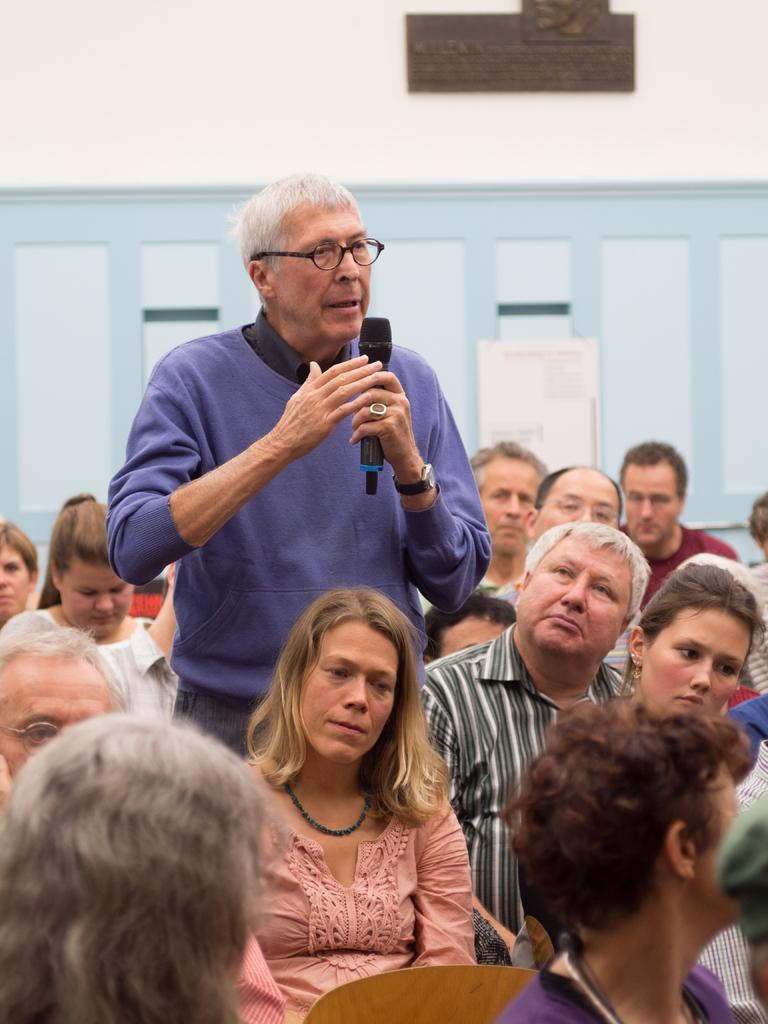What is the person in the image doing? The person is standing and holding a microphone. Who is the person in the image interacting with? The person is standing in front of a group of people who are sitting. What can be seen in the background of the image? There is a wall visible in the background. What type of headphones is the person wearing in the image? There is no mention of headphones in the image; the person is holding a microphone. Can you see a plane flying in the background of the image? There is no mention of a plane in the image; only a wall is visible in the background. 